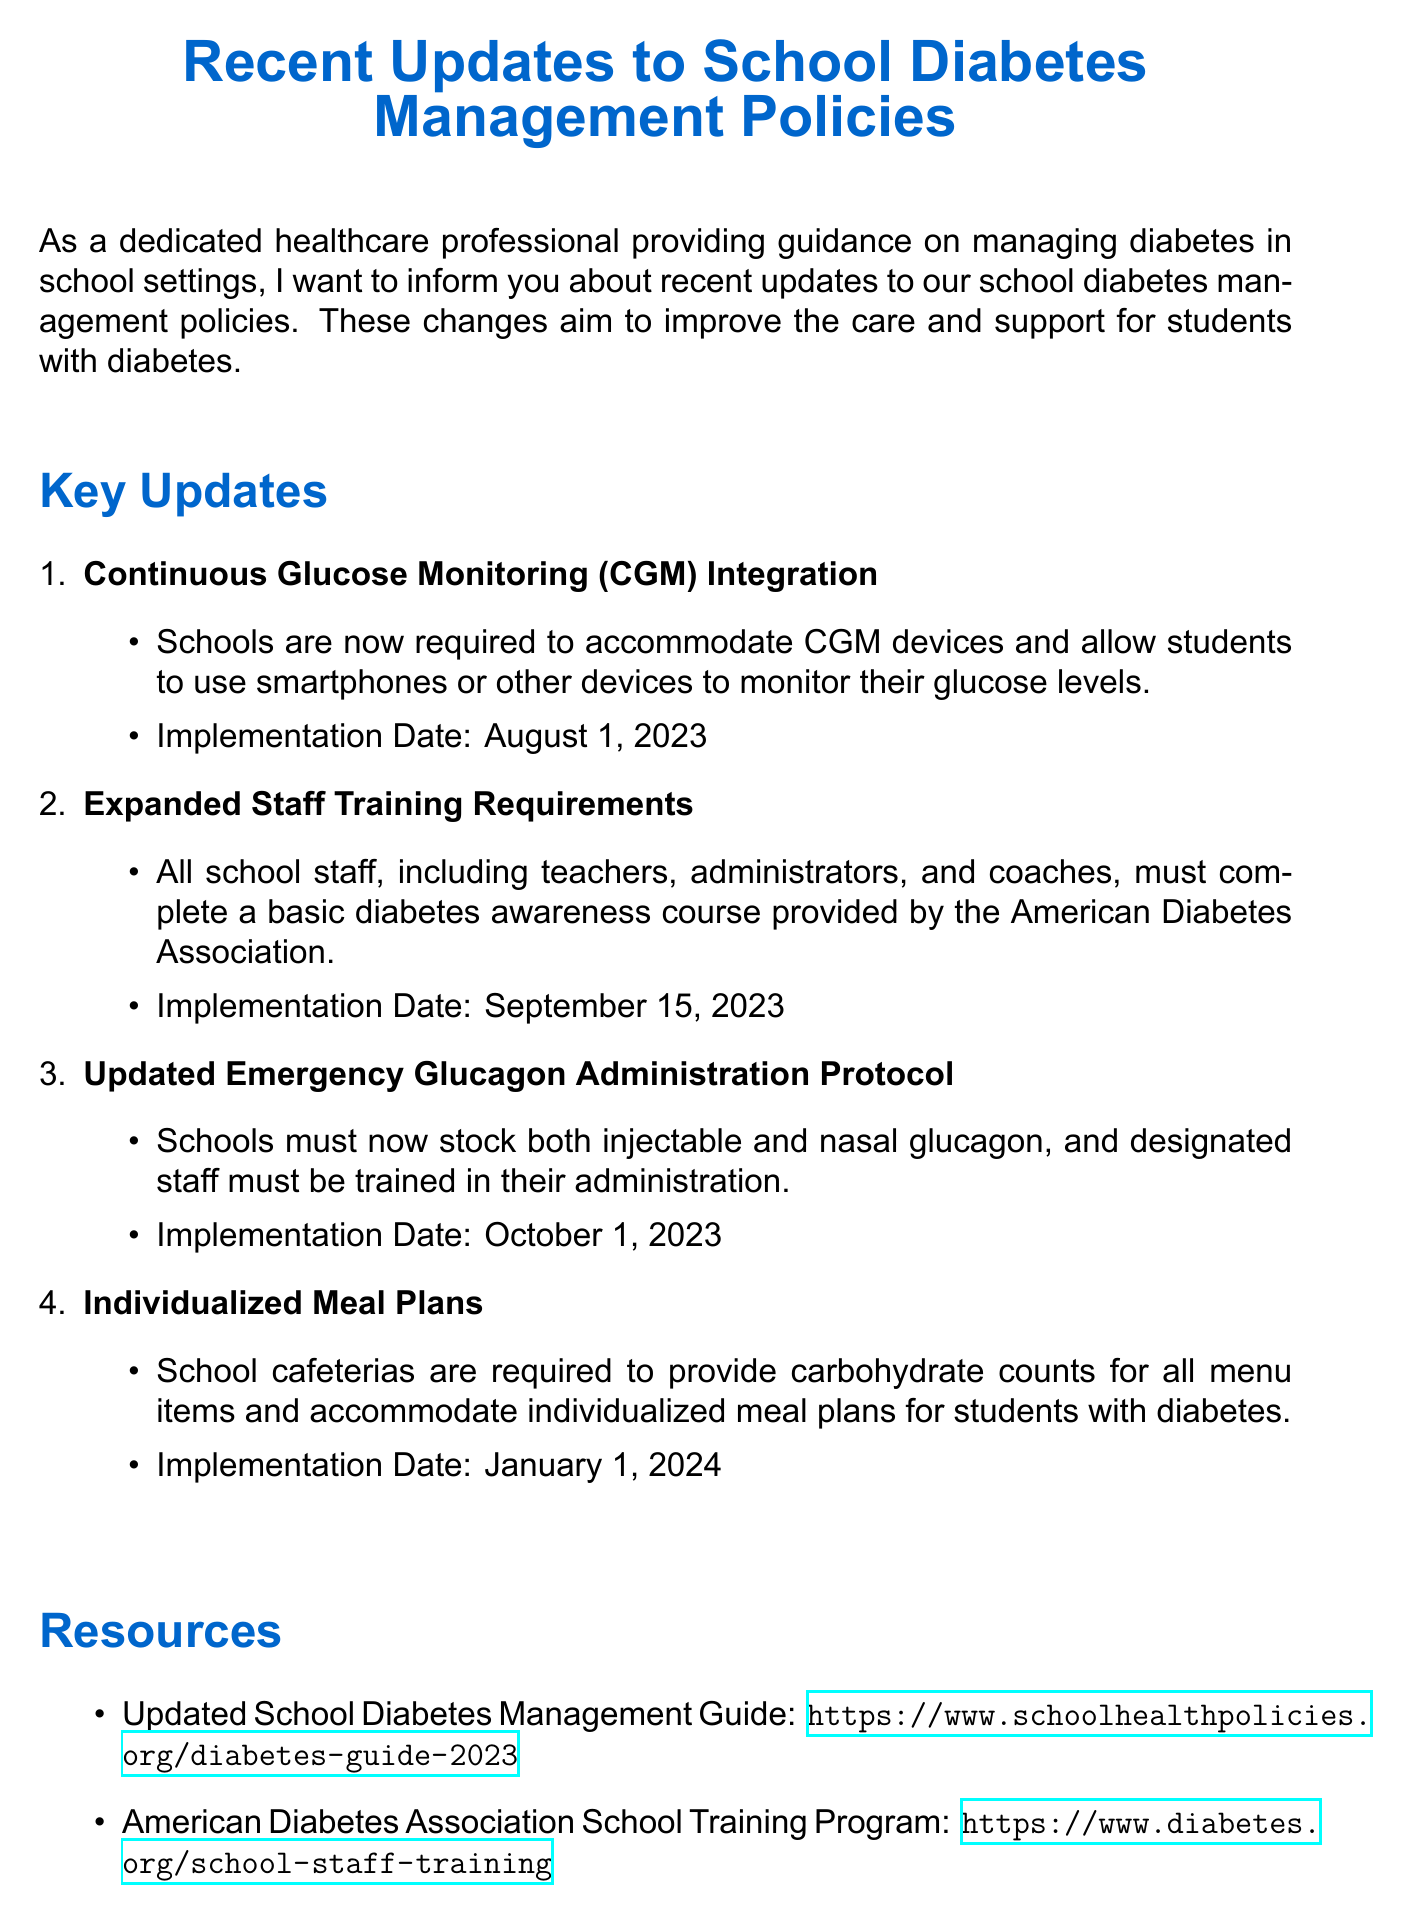What is the title of the memo? The title of the memo is clearly stated at the beginning of the document as "Recent Updates to School Diabetes Management Policies."
Answer: Recent Updates to School Diabetes Management Policies What is the implementation date for CGM Integration? The document mentions that CGM Integration is to be implemented on August 1, 2023.
Answer: August 1, 2023 Who must complete the diabetes awareness course? The memo states that all school staff, including teachers, administrators, and coaches, are required to complete the course.
Answer: All school staff What is the implementation date for Individualized Meal Plans? According to the memo, Individualized Meal Plans will be implemented on January 1, 2024.
Answer: January 1, 2024 What two types of glucagon must schools stock? The document specifies that schools must stock both injectable and nasal glucagon.
Answer: Injectable and nasal glucagon How many key updates are listed in the document? The memo lists four key updates regarding diabetes management policies.
Answer: Four Where can the updated School Diabetes Management Guide be found? The document provides a specific link to access the updated guide, which is https://www.schoolhealthpolicies.org/diabetes-guide-2023.
Answer: https://www.schoolhealthpolicies.org/diabetes-guide-2023 Who is the contact person for questions regarding these updates? The document identifies Dr. Sarah Johnson as the contact person for questions.
Answer: Dr. Sarah Johnson What is the primary focus of these policy updates? The introduction in the memo reflects that the updates aim to improve care and support for students with diabetes.
Answer: Improve care and support for students with diabetes 